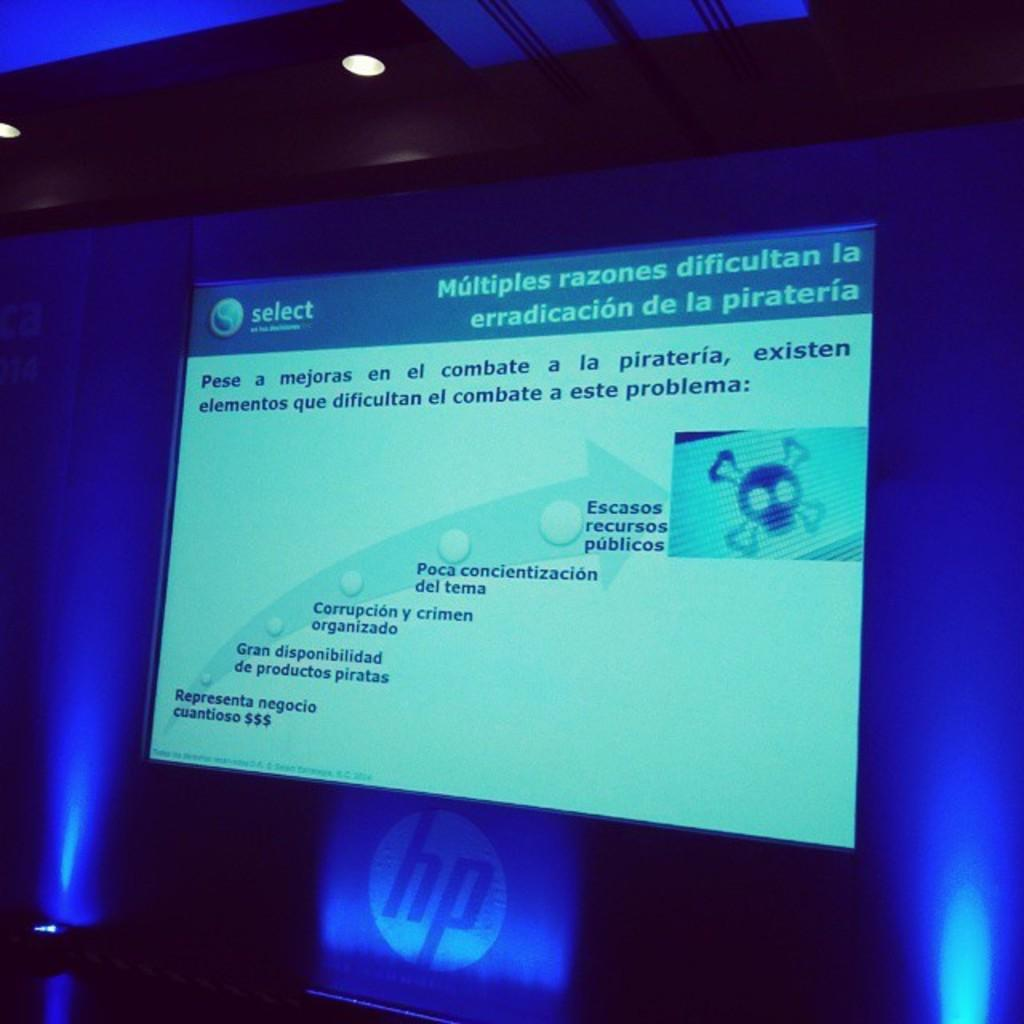<image>
Describe the image concisely. A powerpoint presentation in Spanish on the difficulties of eradicating piracy on a HP screen 